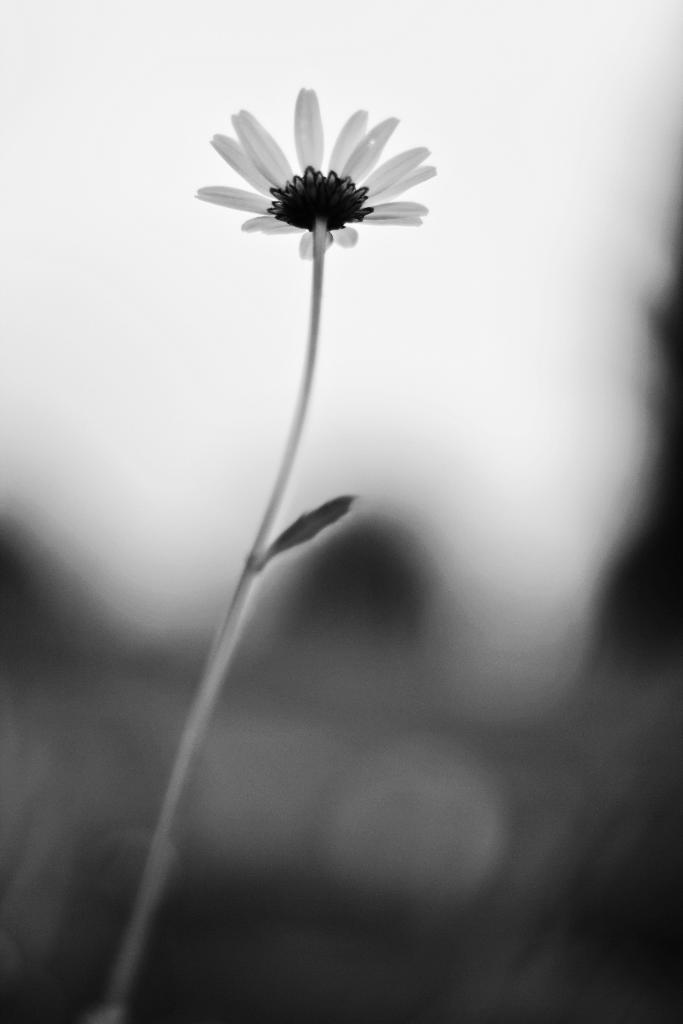What type of plant is visible in the image? There is a flower in the image. Can you describe the flower's structure? The flower has a stem. What other part of the plant can be seen in the image? There is a leaf in the image. How is the image presented in terms of color? The image is in black and white mode. What type of nose can be seen on the flower in the image? There is no nose present on the flower in the image, as flowers do not have noses. 